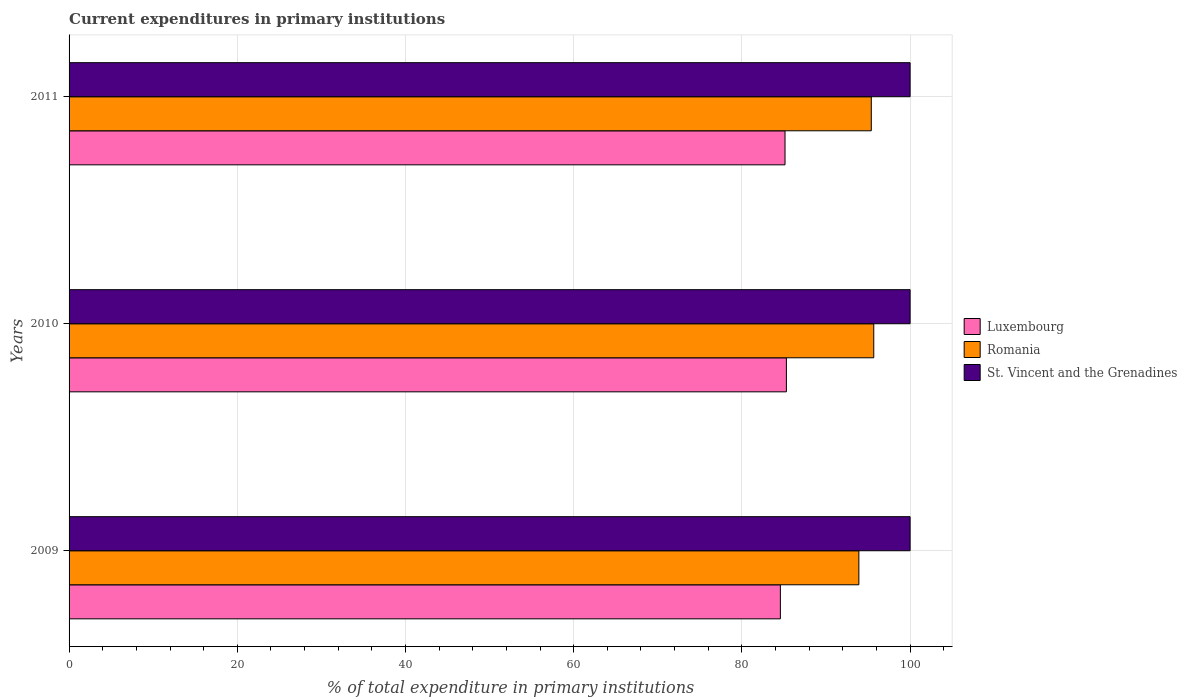How many groups of bars are there?
Provide a succinct answer. 3. Are the number of bars per tick equal to the number of legend labels?
Provide a succinct answer. Yes. How many bars are there on the 2nd tick from the top?
Your response must be concise. 3. What is the current expenditures in primary institutions in Romania in 2010?
Provide a short and direct response. 95.68. Across all years, what is the maximum current expenditures in primary institutions in Romania?
Your answer should be very brief. 95.68. Across all years, what is the minimum current expenditures in primary institutions in Romania?
Your answer should be compact. 93.91. What is the total current expenditures in primary institutions in Romania in the graph?
Your answer should be very brief. 284.97. What is the difference between the current expenditures in primary institutions in Romania in 2009 and that in 2011?
Ensure brevity in your answer.  -1.48. What is the difference between the current expenditures in primary institutions in Luxembourg in 2010 and the current expenditures in primary institutions in Romania in 2009?
Your answer should be very brief. -8.62. What is the average current expenditures in primary institutions in St. Vincent and the Grenadines per year?
Give a very brief answer. 100. In the year 2009, what is the difference between the current expenditures in primary institutions in Luxembourg and current expenditures in primary institutions in St. Vincent and the Grenadines?
Give a very brief answer. -15.43. In how many years, is the current expenditures in primary institutions in Romania greater than 36 %?
Your answer should be compact. 3. What is the ratio of the current expenditures in primary institutions in Luxembourg in 2009 to that in 2010?
Offer a very short reply. 0.99. Is the current expenditures in primary institutions in Luxembourg in 2009 less than that in 2011?
Provide a succinct answer. Yes. Is the difference between the current expenditures in primary institutions in Luxembourg in 2009 and 2011 greater than the difference between the current expenditures in primary institutions in St. Vincent and the Grenadines in 2009 and 2011?
Offer a very short reply. No. What is the difference between the highest and the second highest current expenditures in primary institutions in Romania?
Make the answer very short. 0.29. What is the difference between the highest and the lowest current expenditures in primary institutions in St. Vincent and the Grenadines?
Your answer should be compact. 0. In how many years, is the current expenditures in primary institutions in Romania greater than the average current expenditures in primary institutions in Romania taken over all years?
Provide a succinct answer. 2. What does the 3rd bar from the top in 2009 represents?
Your answer should be very brief. Luxembourg. What does the 2nd bar from the bottom in 2009 represents?
Give a very brief answer. Romania. Is it the case that in every year, the sum of the current expenditures in primary institutions in Luxembourg and current expenditures in primary institutions in St. Vincent and the Grenadines is greater than the current expenditures in primary institutions in Romania?
Offer a very short reply. Yes. How many bars are there?
Ensure brevity in your answer.  9. What is the difference between two consecutive major ticks on the X-axis?
Your answer should be compact. 20. Does the graph contain grids?
Your answer should be very brief. Yes. How are the legend labels stacked?
Provide a short and direct response. Vertical. What is the title of the graph?
Offer a very short reply. Current expenditures in primary institutions. What is the label or title of the X-axis?
Offer a terse response. % of total expenditure in primary institutions. What is the label or title of the Y-axis?
Ensure brevity in your answer.  Years. What is the % of total expenditure in primary institutions of Luxembourg in 2009?
Make the answer very short. 84.57. What is the % of total expenditure in primary institutions of Romania in 2009?
Ensure brevity in your answer.  93.91. What is the % of total expenditure in primary institutions in St. Vincent and the Grenadines in 2009?
Keep it short and to the point. 100. What is the % of total expenditure in primary institutions in Luxembourg in 2010?
Your answer should be very brief. 85.29. What is the % of total expenditure in primary institutions of Romania in 2010?
Offer a very short reply. 95.68. What is the % of total expenditure in primary institutions in St. Vincent and the Grenadines in 2010?
Make the answer very short. 100. What is the % of total expenditure in primary institutions of Luxembourg in 2011?
Ensure brevity in your answer.  85.13. What is the % of total expenditure in primary institutions of Romania in 2011?
Offer a terse response. 95.39. Across all years, what is the maximum % of total expenditure in primary institutions of Luxembourg?
Your response must be concise. 85.29. Across all years, what is the maximum % of total expenditure in primary institutions in Romania?
Make the answer very short. 95.68. Across all years, what is the maximum % of total expenditure in primary institutions in St. Vincent and the Grenadines?
Provide a succinct answer. 100. Across all years, what is the minimum % of total expenditure in primary institutions of Luxembourg?
Your response must be concise. 84.57. Across all years, what is the minimum % of total expenditure in primary institutions of Romania?
Your answer should be compact. 93.91. What is the total % of total expenditure in primary institutions in Luxembourg in the graph?
Your response must be concise. 254.99. What is the total % of total expenditure in primary institutions in Romania in the graph?
Your answer should be compact. 284.97. What is the total % of total expenditure in primary institutions in St. Vincent and the Grenadines in the graph?
Provide a succinct answer. 300. What is the difference between the % of total expenditure in primary institutions of Luxembourg in 2009 and that in 2010?
Provide a succinct answer. -0.72. What is the difference between the % of total expenditure in primary institutions of Romania in 2009 and that in 2010?
Keep it short and to the point. -1.77. What is the difference between the % of total expenditure in primary institutions in St. Vincent and the Grenadines in 2009 and that in 2010?
Your answer should be compact. 0. What is the difference between the % of total expenditure in primary institutions of Luxembourg in 2009 and that in 2011?
Ensure brevity in your answer.  -0.55. What is the difference between the % of total expenditure in primary institutions of Romania in 2009 and that in 2011?
Your response must be concise. -1.48. What is the difference between the % of total expenditure in primary institutions of Luxembourg in 2010 and that in 2011?
Ensure brevity in your answer.  0.16. What is the difference between the % of total expenditure in primary institutions in Romania in 2010 and that in 2011?
Keep it short and to the point. 0.29. What is the difference between the % of total expenditure in primary institutions in St. Vincent and the Grenadines in 2010 and that in 2011?
Keep it short and to the point. 0. What is the difference between the % of total expenditure in primary institutions in Luxembourg in 2009 and the % of total expenditure in primary institutions in Romania in 2010?
Keep it short and to the point. -11.1. What is the difference between the % of total expenditure in primary institutions of Luxembourg in 2009 and the % of total expenditure in primary institutions of St. Vincent and the Grenadines in 2010?
Give a very brief answer. -15.43. What is the difference between the % of total expenditure in primary institutions of Romania in 2009 and the % of total expenditure in primary institutions of St. Vincent and the Grenadines in 2010?
Make the answer very short. -6.09. What is the difference between the % of total expenditure in primary institutions in Luxembourg in 2009 and the % of total expenditure in primary institutions in Romania in 2011?
Give a very brief answer. -10.81. What is the difference between the % of total expenditure in primary institutions in Luxembourg in 2009 and the % of total expenditure in primary institutions in St. Vincent and the Grenadines in 2011?
Offer a very short reply. -15.43. What is the difference between the % of total expenditure in primary institutions in Romania in 2009 and the % of total expenditure in primary institutions in St. Vincent and the Grenadines in 2011?
Give a very brief answer. -6.09. What is the difference between the % of total expenditure in primary institutions of Luxembourg in 2010 and the % of total expenditure in primary institutions of Romania in 2011?
Your answer should be compact. -10.1. What is the difference between the % of total expenditure in primary institutions in Luxembourg in 2010 and the % of total expenditure in primary institutions in St. Vincent and the Grenadines in 2011?
Keep it short and to the point. -14.71. What is the difference between the % of total expenditure in primary institutions of Romania in 2010 and the % of total expenditure in primary institutions of St. Vincent and the Grenadines in 2011?
Offer a terse response. -4.32. What is the average % of total expenditure in primary institutions of Luxembourg per year?
Keep it short and to the point. 85. What is the average % of total expenditure in primary institutions of Romania per year?
Give a very brief answer. 94.99. In the year 2009, what is the difference between the % of total expenditure in primary institutions of Luxembourg and % of total expenditure in primary institutions of Romania?
Provide a succinct answer. -9.33. In the year 2009, what is the difference between the % of total expenditure in primary institutions in Luxembourg and % of total expenditure in primary institutions in St. Vincent and the Grenadines?
Ensure brevity in your answer.  -15.43. In the year 2009, what is the difference between the % of total expenditure in primary institutions in Romania and % of total expenditure in primary institutions in St. Vincent and the Grenadines?
Make the answer very short. -6.09. In the year 2010, what is the difference between the % of total expenditure in primary institutions of Luxembourg and % of total expenditure in primary institutions of Romania?
Give a very brief answer. -10.39. In the year 2010, what is the difference between the % of total expenditure in primary institutions of Luxembourg and % of total expenditure in primary institutions of St. Vincent and the Grenadines?
Offer a terse response. -14.71. In the year 2010, what is the difference between the % of total expenditure in primary institutions in Romania and % of total expenditure in primary institutions in St. Vincent and the Grenadines?
Provide a short and direct response. -4.32. In the year 2011, what is the difference between the % of total expenditure in primary institutions in Luxembourg and % of total expenditure in primary institutions in Romania?
Ensure brevity in your answer.  -10.26. In the year 2011, what is the difference between the % of total expenditure in primary institutions of Luxembourg and % of total expenditure in primary institutions of St. Vincent and the Grenadines?
Offer a very short reply. -14.87. In the year 2011, what is the difference between the % of total expenditure in primary institutions in Romania and % of total expenditure in primary institutions in St. Vincent and the Grenadines?
Your answer should be compact. -4.61. What is the ratio of the % of total expenditure in primary institutions of Luxembourg in 2009 to that in 2010?
Your answer should be compact. 0.99. What is the ratio of the % of total expenditure in primary institutions of Romania in 2009 to that in 2010?
Offer a terse response. 0.98. What is the ratio of the % of total expenditure in primary institutions of St. Vincent and the Grenadines in 2009 to that in 2010?
Make the answer very short. 1. What is the ratio of the % of total expenditure in primary institutions in Luxembourg in 2009 to that in 2011?
Provide a succinct answer. 0.99. What is the ratio of the % of total expenditure in primary institutions of Romania in 2009 to that in 2011?
Make the answer very short. 0.98. What is the ratio of the % of total expenditure in primary institutions of St. Vincent and the Grenadines in 2009 to that in 2011?
Provide a short and direct response. 1. What is the ratio of the % of total expenditure in primary institutions in Romania in 2010 to that in 2011?
Your response must be concise. 1. What is the difference between the highest and the second highest % of total expenditure in primary institutions of Luxembourg?
Provide a succinct answer. 0.16. What is the difference between the highest and the second highest % of total expenditure in primary institutions of Romania?
Make the answer very short. 0.29. What is the difference between the highest and the second highest % of total expenditure in primary institutions in St. Vincent and the Grenadines?
Your answer should be very brief. 0. What is the difference between the highest and the lowest % of total expenditure in primary institutions of Luxembourg?
Make the answer very short. 0.72. What is the difference between the highest and the lowest % of total expenditure in primary institutions of Romania?
Your answer should be compact. 1.77. 